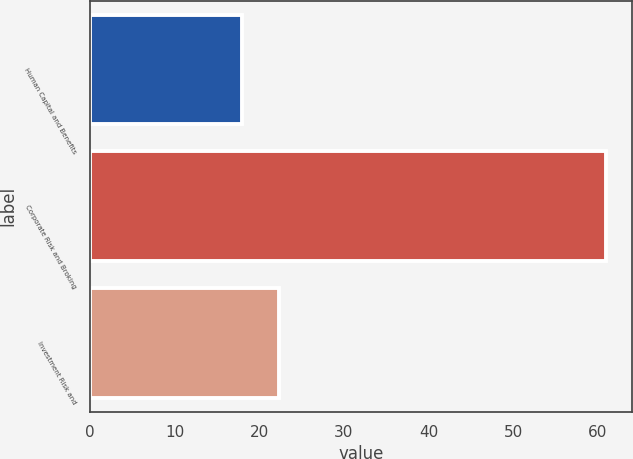<chart> <loc_0><loc_0><loc_500><loc_500><bar_chart><fcel>Human Capital and Benefits<fcel>Corporate Risk and Broking<fcel>Investment Risk and<nl><fcel>18<fcel>61<fcel>22.3<nl></chart> 